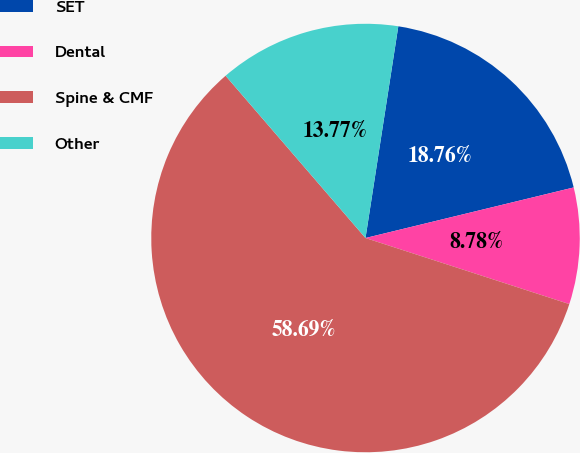Convert chart. <chart><loc_0><loc_0><loc_500><loc_500><pie_chart><fcel>SET<fcel>Dental<fcel>Spine & CMF<fcel>Other<nl><fcel>18.76%<fcel>8.78%<fcel>58.68%<fcel>13.77%<nl></chart> 